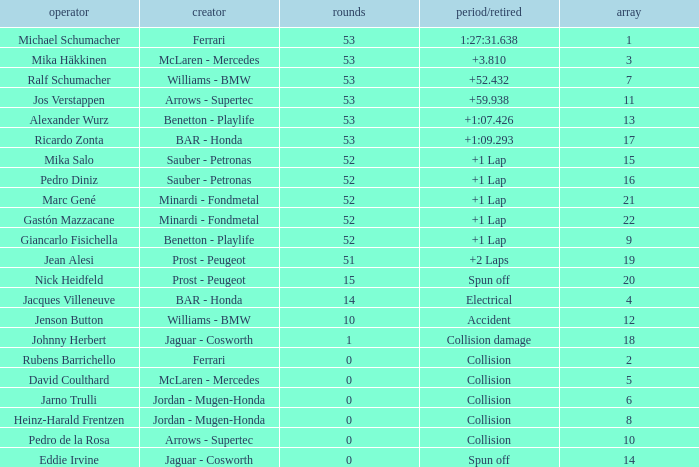What is the average Laps for a grid smaller than 17, and a Constructor of williams - bmw, driven by jenson button? 10.0. 